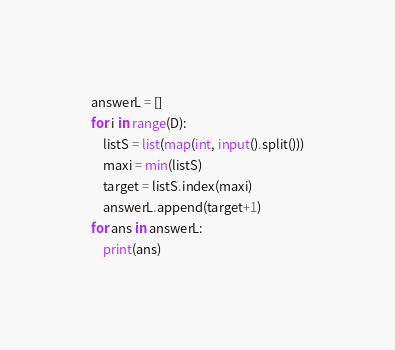Convert code to text. <code><loc_0><loc_0><loc_500><loc_500><_Python_>answerL = []
for i in range(D):
    listS = list(map(int, input().split()))
    maxi = min(listS)
    target = listS.index(maxi)
    answerL.append(target+1)
for ans in answerL:
    print(ans)</code> 